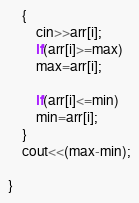Convert code to text. <code><loc_0><loc_0><loc_500><loc_500><_C++_>	{
		cin>>arr[i];
		if(arr[i]>=max)
     	max=arr[i];
		
		if(arr[i]<=min)
		min=arr[i];
	}
	cout<<(max-min);
	
}

</code> 